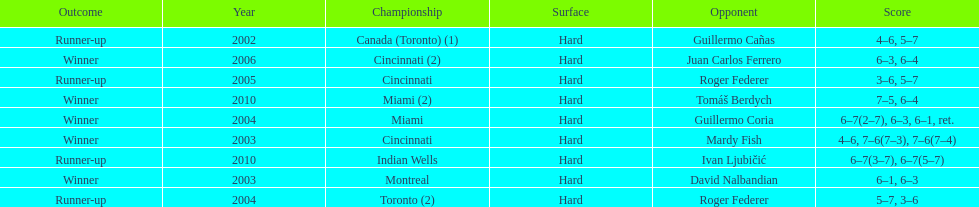How many times was the championship in miami? 2. 